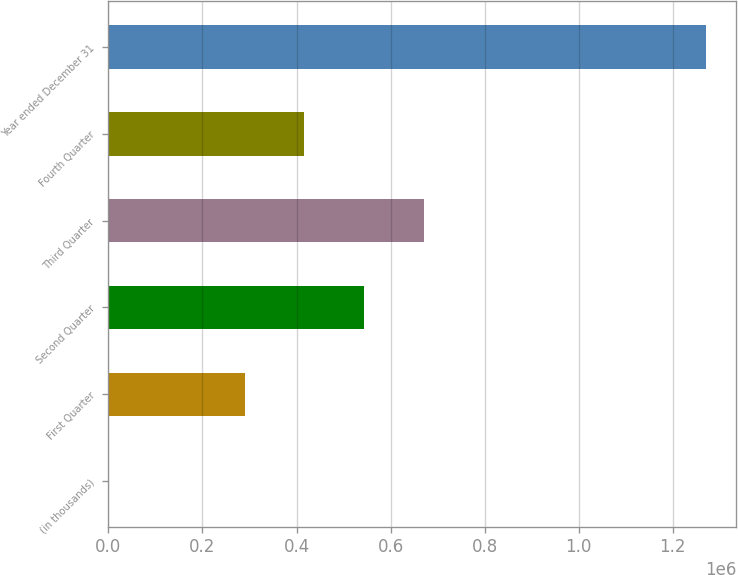Convert chart to OTSL. <chart><loc_0><loc_0><loc_500><loc_500><bar_chart><fcel>(in thousands)<fcel>First Quarter<fcel>Second Quarter<fcel>Third Quarter<fcel>Fourth Quarter<fcel>Year ended December 31<nl><fcel>2012<fcel>289465<fcel>543244<fcel>670134<fcel>416355<fcel>1.27091e+06<nl></chart> 